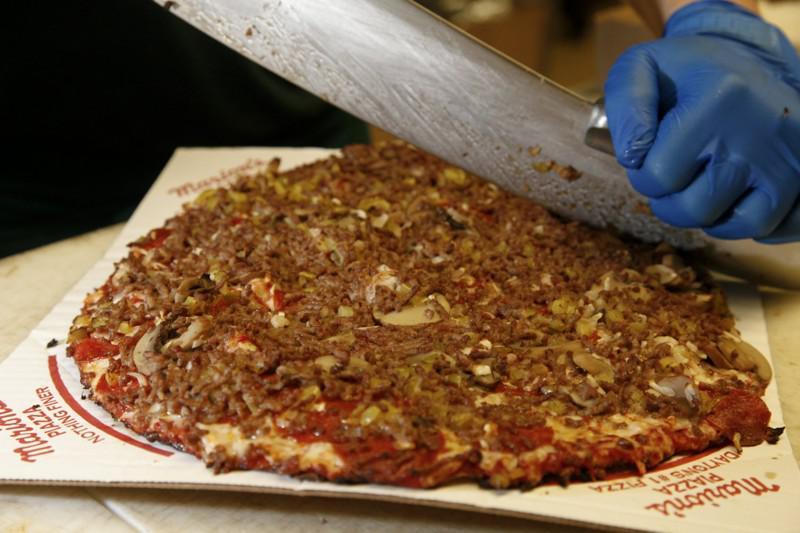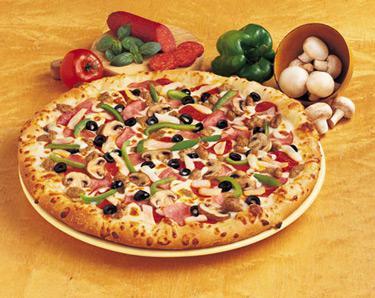The first image is the image on the left, the second image is the image on the right. Assess this claim about the two images: "The pizza in the image to the right has green peppers on it.". Correct or not? Answer yes or no. Yes. The first image is the image on the left, the second image is the image on the right. Given the left and right images, does the statement "The right image shows one complete unsliced pizza with multiple hamburgers on top of it, and the left image shows a pizza with at least one slice not on its round dark pan." hold true? Answer yes or no. No. 